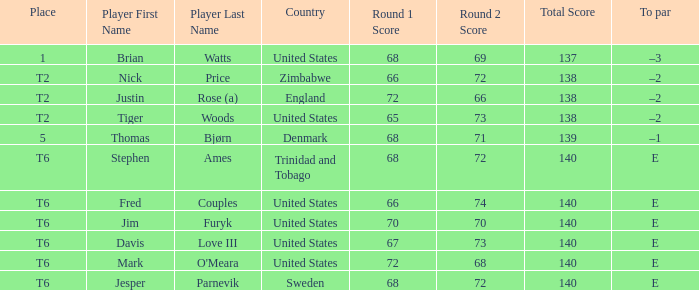For the player who achieved a 139 score by scoring 68-71, what was the to par? –1. 